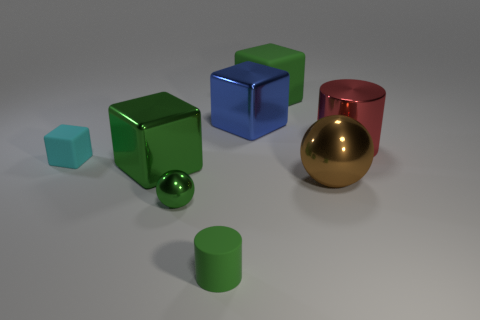Subtract all red balls. How many green blocks are left? 2 Subtract 1 cubes. How many cubes are left? 3 Subtract all large cubes. How many cubes are left? 1 Subtract all blue cubes. How many cubes are left? 3 Subtract all gray cubes. Subtract all gray cylinders. How many cubes are left? 4 Add 2 large metal cylinders. How many objects exist? 10 Add 8 big purple rubber cylinders. How many big purple rubber cylinders exist? 8 Subtract 1 green balls. How many objects are left? 7 Subtract all cylinders. How many objects are left? 6 Subtract all big green metal things. Subtract all tiny green matte objects. How many objects are left? 6 